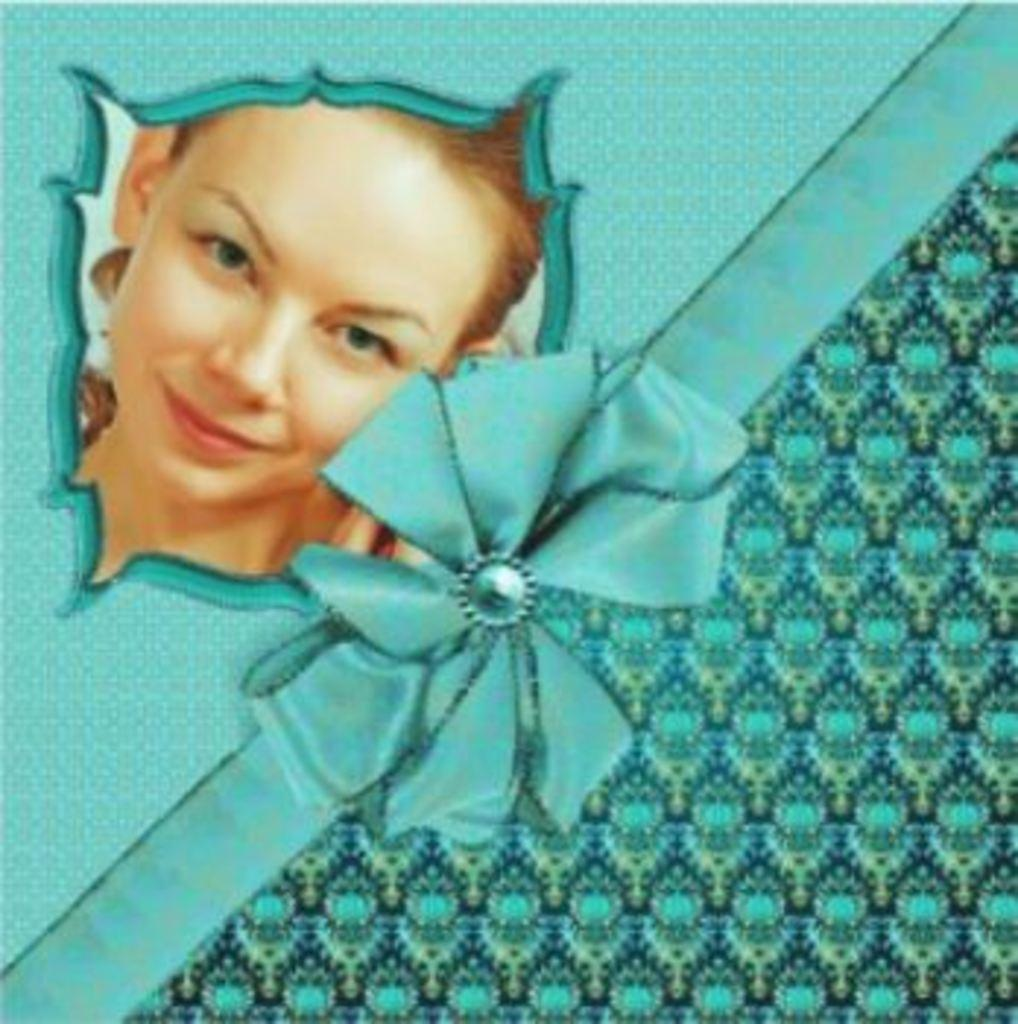What is depicted on the left side of the image? There is a picture of a woman on the left side of the image. What color is the background of the image? The background of the image is blue. Can you see an owl in the image? No, there is no owl present in the image. What beliefs are represented in the image? The image does not depict any specific beliefs. 